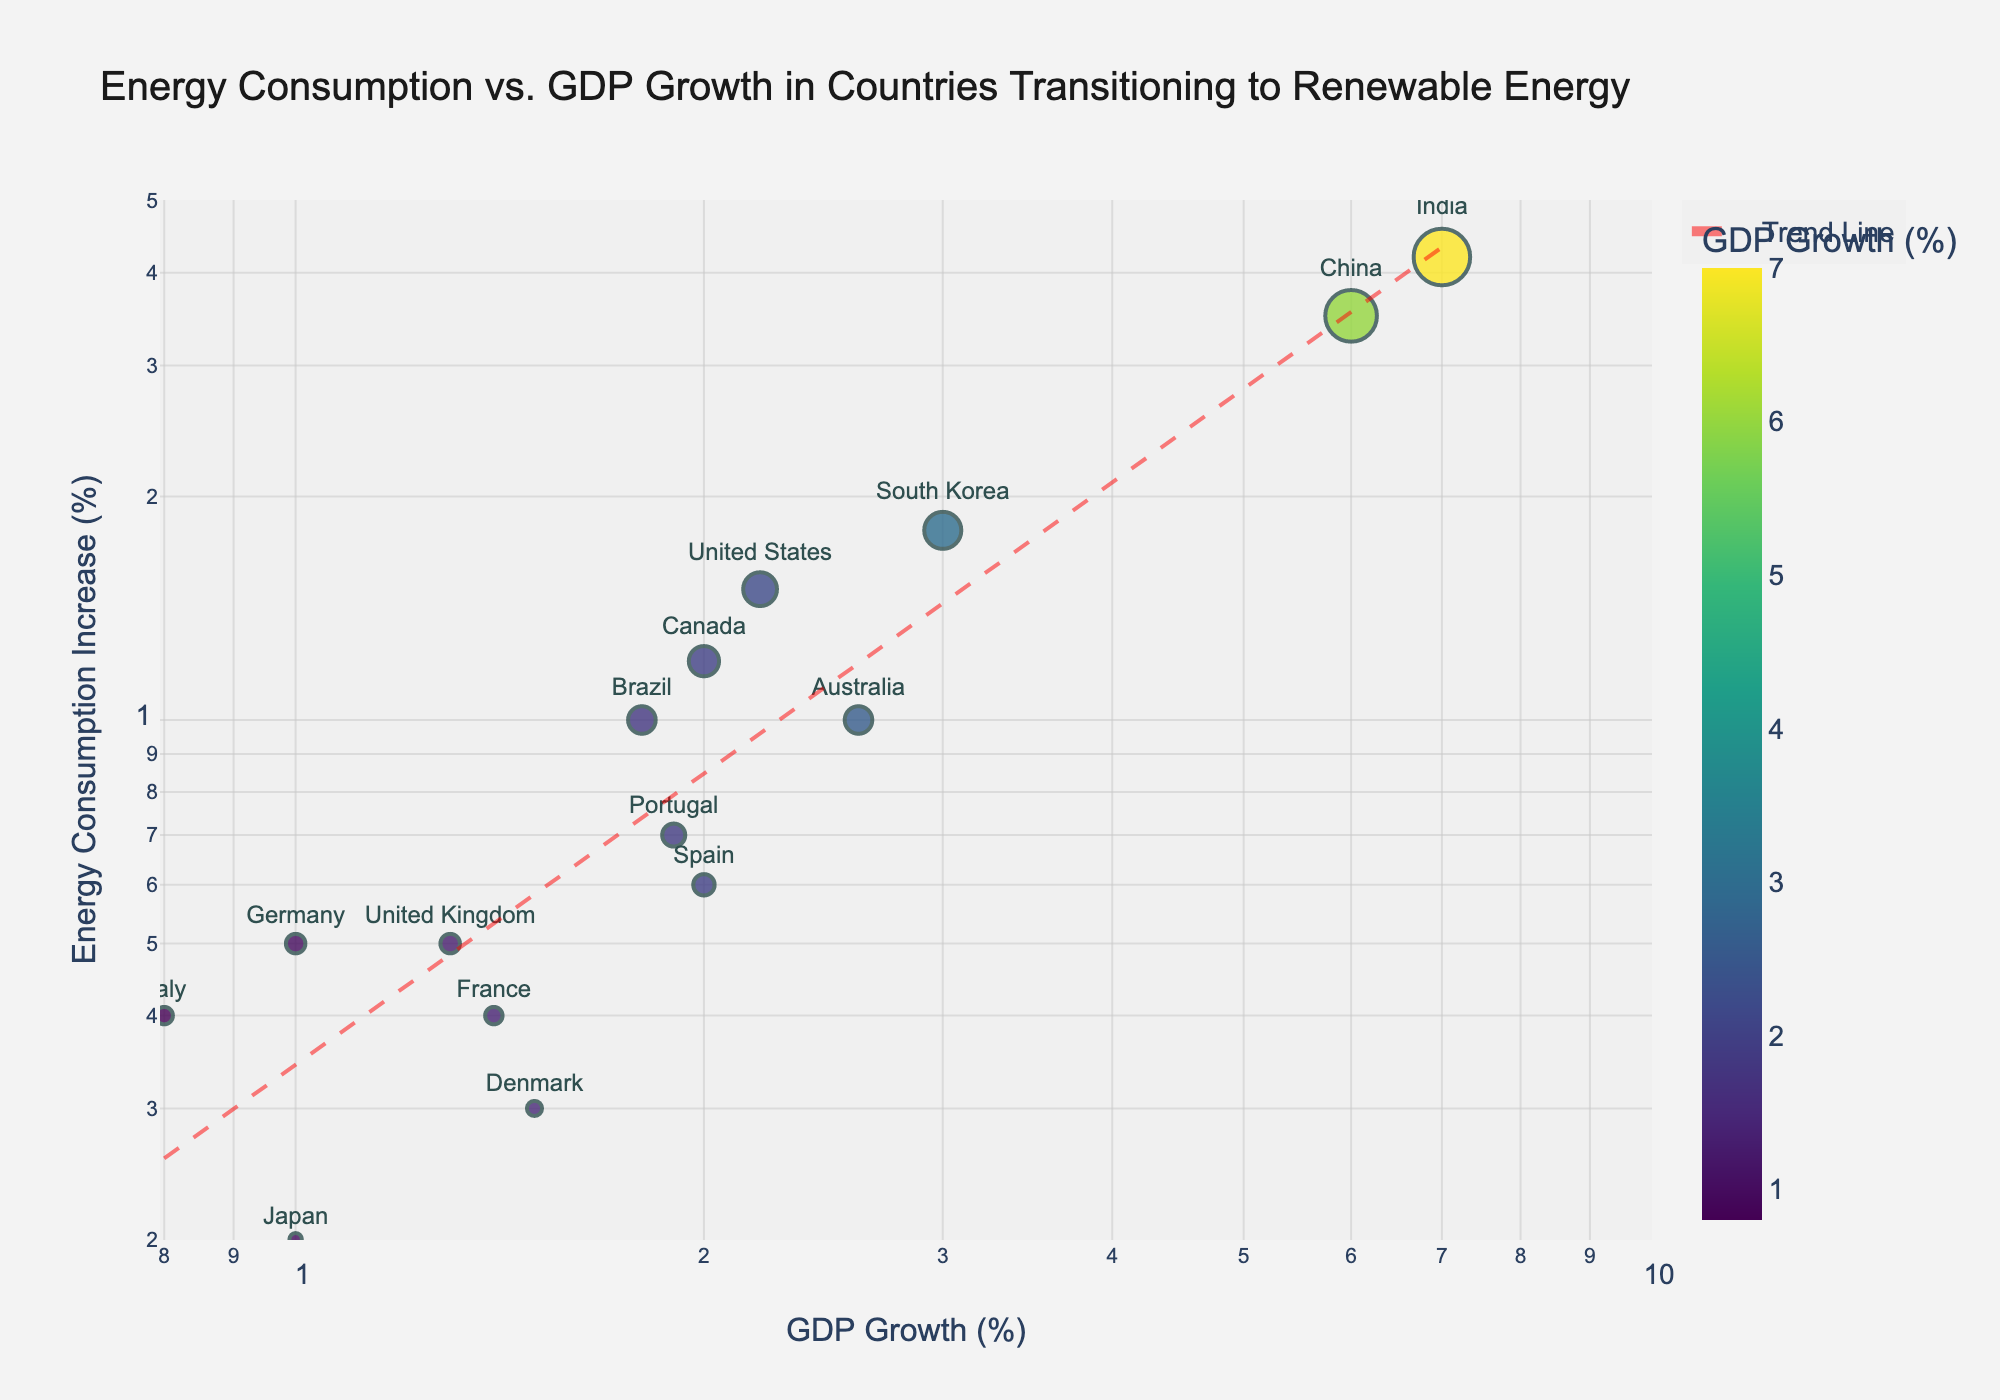What is the title of the scatter plot? The title is typically displayed prominently at the top of the scatter plot. Here, it indicates the relationship being visualized.
Answer: Energy Consumption vs. GDP Growth in Countries Transitioning to Renewable Energy How many countries are represented in the scatter plot? By counting the individual data points, which represent different countries, we can determine the total number of countries.
Answer: 15 Which country shows the highest GDP growth? By examining the x-axis, which represents GDP growth on a log scale, and identifying the furthest right data point, we find the country with the highest GDP growth.
Answer: India Which country has the lowest increase in energy consumption while still exhibiting GDP growth? By looking at the y-axis (energy consumption increase on a log scale) and identifying the lowest point that is still above zero, we can determine the country.
Answer: Japan What trend can be observed in the relationship between GDP growth and energy consumption increase? By examining the trend line added to the scatter plot, we can identify the overall pattern or direction of the data points.
Answer: Positive correlation Which countries have similar increases in energy consumption but differ significantly in GDP growth? By finding pairs of countries whose points are aligned vertically but not horizontally, we can identify this relationship.
Answer: United States and Canada Identify the cluster of countries with low GDP growth and their corresponding spread in energy consumption increase. By focusing on the left side of the scatter plot, where GDP growth values are lower, and noting the range of their y-axis values (energy consumption increase), we define this cluster.
Answer: Germany, Denmark, France, United Kingdom, Japan, Italy Which country has both moderate GDP growth and moderate energy consumption increase? By identifying a central point in both the x-axis and y-axis ranges, we can pinpoint which country's data lies approximately in the middle.
Answer: Brazil What is the color scheme used for indicating GDP growth, and how does it vary across the countries? Observing the scatter plot's legend and the range of colors used for the data points, we can describe the color variations indicative of GDP growth.
Answer: Viridis color scale; it ranges from green to purple How does the energy consumption increase of Spain compare to that of China? By locating the data points for Spain and China and comparing their positions on the y-axis (energy consumption increase), we can see the difference.
Answer: Spain has a lower energy consumption increase than China 